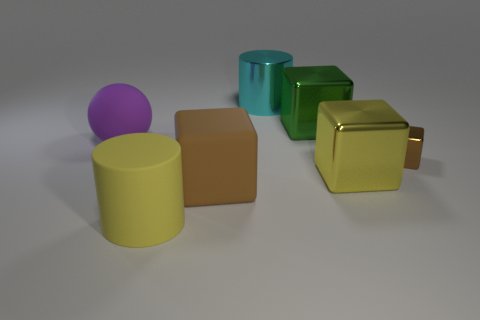Add 1 large metallic blocks. How many objects exist? 8 Subtract all cubes. How many objects are left? 3 Add 2 big green things. How many big green things exist? 3 Subtract 0 cyan blocks. How many objects are left? 7 Subtract all matte balls. Subtract all big metal cylinders. How many objects are left? 5 Add 3 big yellow blocks. How many big yellow blocks are left? 4 